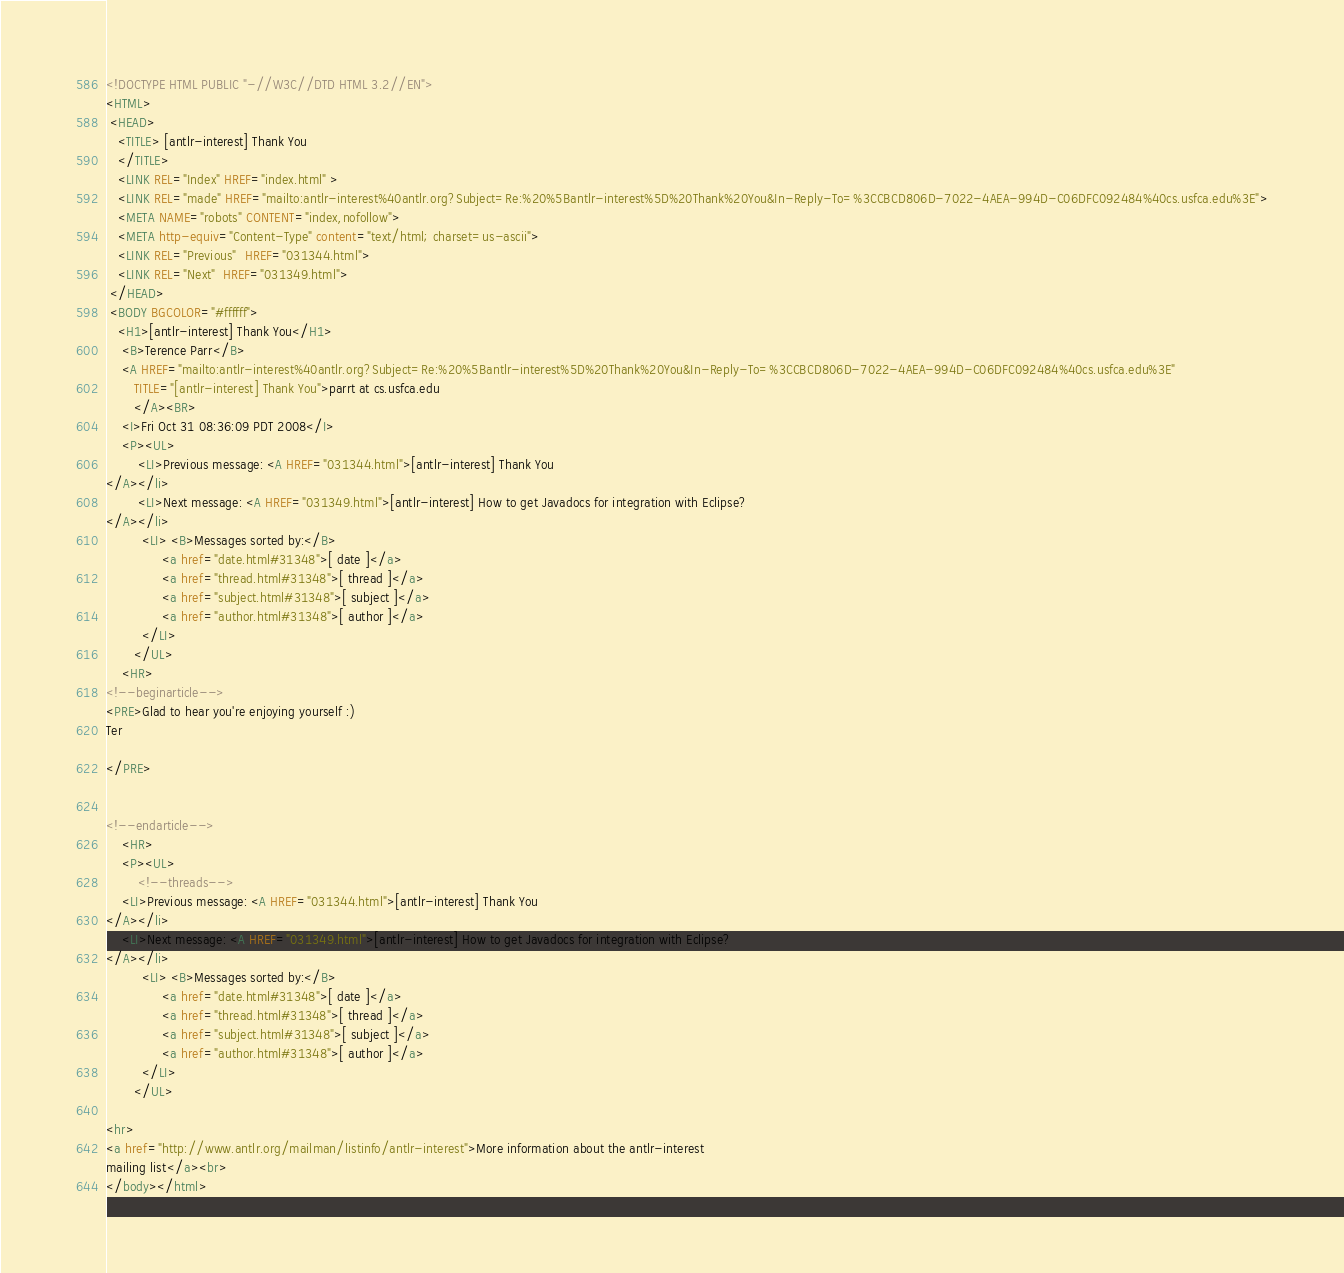<code> <loc_0><loc_0><loc_500><loc_500><_HTML_><!DOCTYPE HTML PUBLIC "-//W3C//DTD HTML 3.2//EN">
<HTML>
 <HEAD>
   <TITLE> [antlr-interest] Thank You
   </TITLE>
   <LINK REL="Index" HREF="index.html" >
   <LINK REL="made" HREF="mailto:antlr-interest%40antlr.org?Subject=Re:%20%5Bantlr-interest%5D%20Thank%20You&In-Reply-To=%3CCBCD806D-7022-4AEA-994D-C06DFC092484%40cs.usfca.edu%3E">
   <META NAME="robots" CONTENT="index,nofollow">
   <META http-equiv="Content-Type" content="text/html; charset=us-ascii">
   <LINK REL="Previous"  HREF="031344.html">
   <LINK REL="Next"  HREF="031349.html">
 </HEAD>
 <BODY BGCOLOR="#ffffff">
   <H1>[antlr-interest] Thank You</H1>
    <B>Terence Parr</B> 
    <A HREF="mailto:antlr-interest%40antlr.org?Subject=Re:%20%5Bantlr-interest%5D%20Thank%20You&In-Reply-To=%3CCBCD806D-7022-4AEA-994D-C06DFC092484%40cs.usfca.edu%3E"
       TITLE="[antlr-interest] Thank You">parrt at cs.usfca.edu
       </A><BR>
    <I>Fri Oct 31 08:36:09 PDT 2008</I>
    <P><UL>
        <LI>Previous message: <A HREF="031344.html">[antlr-interest] Thank You
</A></li>
        <LI>Next message: <A HREF="031349.html">[antlr-interest] How to get Javadocs for integration with Eclipse?
</A></li>
         <LI> <B>Messages sorted by:</B> 
              <a href="date.html#31348">[ date ]</a>
              <a href="thread.html#31348">[ thread ]</a>
              <a href="subject.html#31348">[ subject ]</a>
              <a href="author.html#31348">[ author ]</a>
         </LI>
       </UL>
    <HR>  
<!--beginarticle-->
<PRE>Glad to hear you're enjoying yourself :)
Ter

</PRE>


<!--endarticle-->
    <HR>
    <P><UL>
        <!--threads-->
	<LI>Previous message: <A HREF="031344.html">[antlr-interest] Thank You
</A></li>
	<LI>Next message: <A HREF="031349.html">[antlr-interest] How to get Javadocs for integration with Eclipse?
</A></li>
         <LI> <B>Messages sorted by:</B> 
              <a href="date.html#31348">[ date ]</a>
              <a href="thread.html#31348">[ thread ]</a>
              <a href="subject.html#31348">[ subject ]</a>
              <a href="author.html#31348">[ author ]</a>
         </LI>
       </UL>

<hr>
<a href="http://www.antlr.org/mailman/listinfo/antlr-interest">More information about the antlr-interest
mailing list</a><br>
</body></html>
</code> 